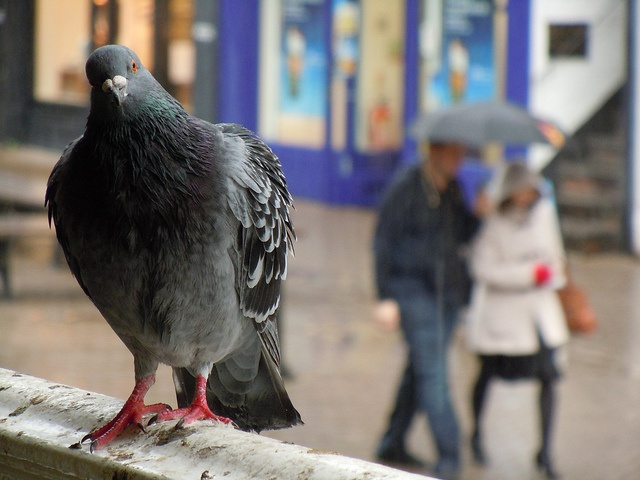Describe the objects in this image and their specific colors. I can see bird in black, gray, darkgray, and maroon tones, people in black, gray, and darkblue tones, people in black, lightgray, darkgray, and gray tones, umbrella in black, darkgray, and gray tones, and handbag in black, brown, tan, and salmon tones in this image. 